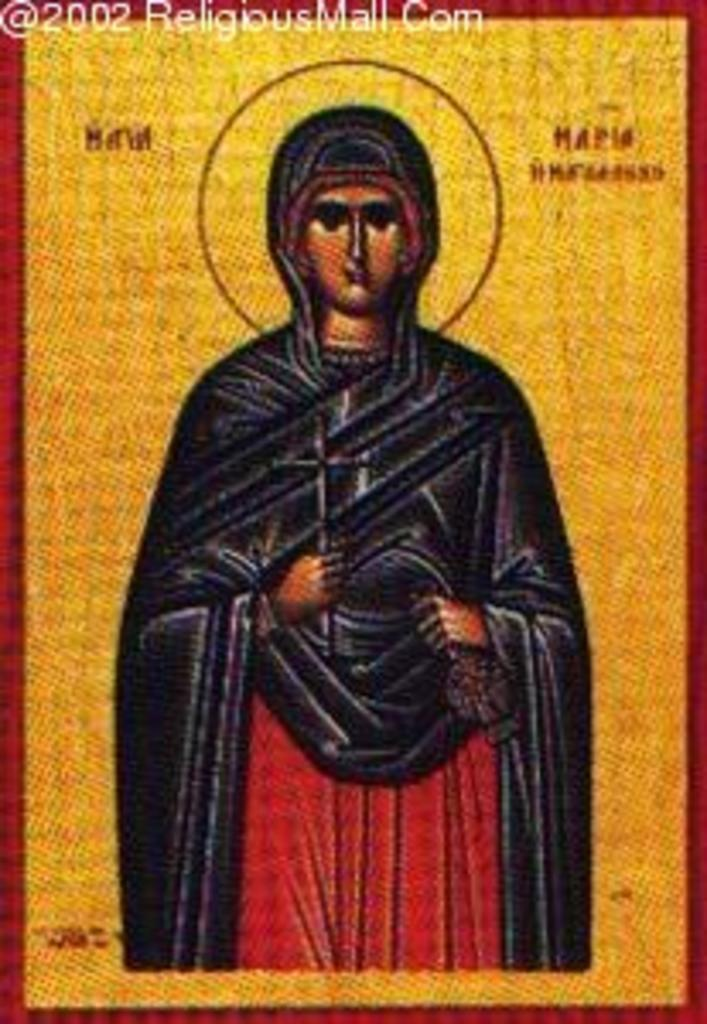What type of visual content is the image? The image is a poster. What is the main subject of the poster? There is a person depicted in the poster. Are there any words or phrases on the poster? Yes, there is text present in the poster. Can you describe any additional elements on the poster? There is a watermark at the top of the image. What type of dinner is being served in the image? There is no dinner present in the image; it is a poster with a person, text, and a watermark. Can you describe the curve of the plane in the image? There is no plane present in the image, so it is not possible to describe the curve of a plane. 